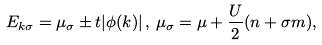Convert formula to latex. <formula><loc_0><loc_0><loc_500><loc_500>E _ { k \sigma } = \mu _ { \sigma } \pm t | \phi ( { k } ) | \, , \, \mu _ { \sigma } = \mu + \frac { U } { 2 } ( n + \sigma m ) ,</formula> 